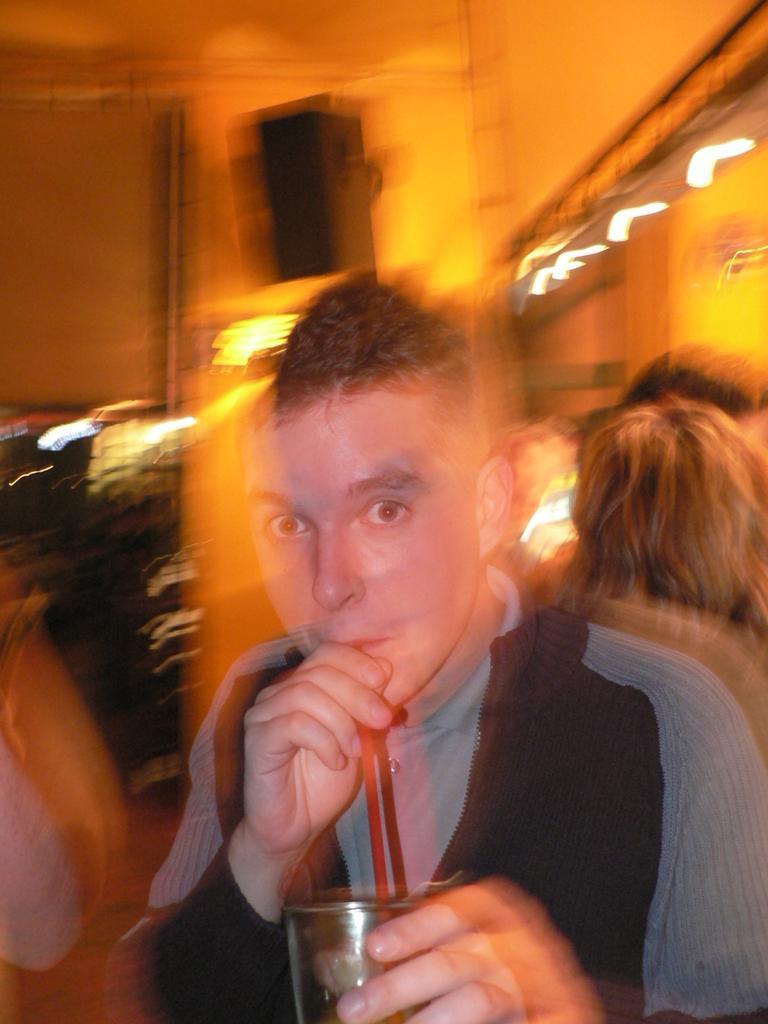Can you describe this image briefly? This picture seems to be an edited image. In the foreground we can see a person holding a glass and a straw and seems to be drinking. The background of the image is blurry and we can see the group of persons, lights and some other objects in the background. 